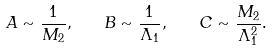Convert formula to latex. <formula><loc_0><loc_0><loc_500><loc_500>A \sim \frac { 1 } { M _ { 2 } } , \quad B \sim \frac { 1 } { \Lambda _ { 1 } } , \quad C \sim \frac { M _ { 2 } } { \Lambda _ { 1 } ^ { 2 } } .</formula> 